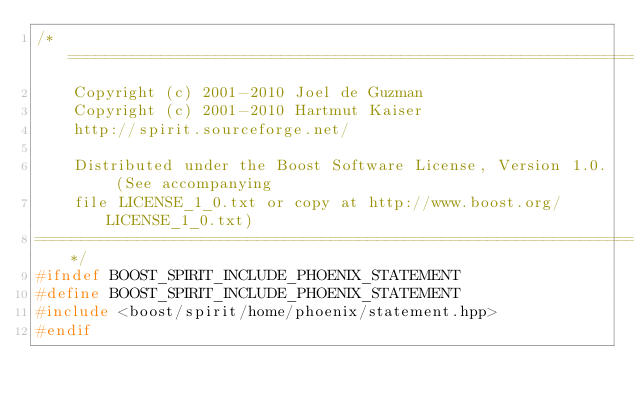Convert code to text. <code><loc_0><loc_0><loc_500><loc_500><_C++_>/*=============================================================================
    Copyright (c) 2001-2010 Joel de Guzman
    Copyright (c) 2001-2010 Hartmut Kaiser
    http://spirit.sourceforge.net/

    Distributed under the Boost Software License, Version 1.0. (See accompanying
    file LICENSE_1_0.txt or copy at http://www.boost.org/LICENSE_1_0.txt)
=============================================================================*/
#ifndef BOOST_SPIRIT_INCLUDE_PHOENIX_STATEMENT
#define BOOST_SPIRIT_INCLUDE_PHOENIX_STATEMENT
#include <boost/spirit/home/phoenix/statement.hpp>
#endif
</code> 